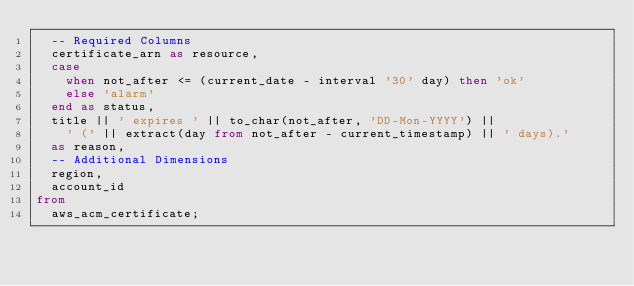Convert code to text. <code><loc_0><loc_0><loc_500><loc_500><_SQL_>  -- Required Columns
  certificate_arn as resource,
  case
    when not_after <= (current_date - interval '30' day) then 'ok'
    else 'alarm'
  end as status,
  title || ' expires ' || to_char(not_after, 'DD-Mon-YYYY') ||
    ' (' || extract(day from not_after - current_timestamp) || ' days).'
  as reason,
  -- Additional Dimensions
  region,
  account_id
from
  aws_acm_certificate;
</code> 